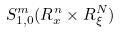Convert formula to latex. <formula><loc_0><loc_0><loc_500><loc_500>S _ { 1 , 0 } ^ { m } ( R _ { x } ^ { n } \times R _ { \xi } ^ { N } )</formula> 